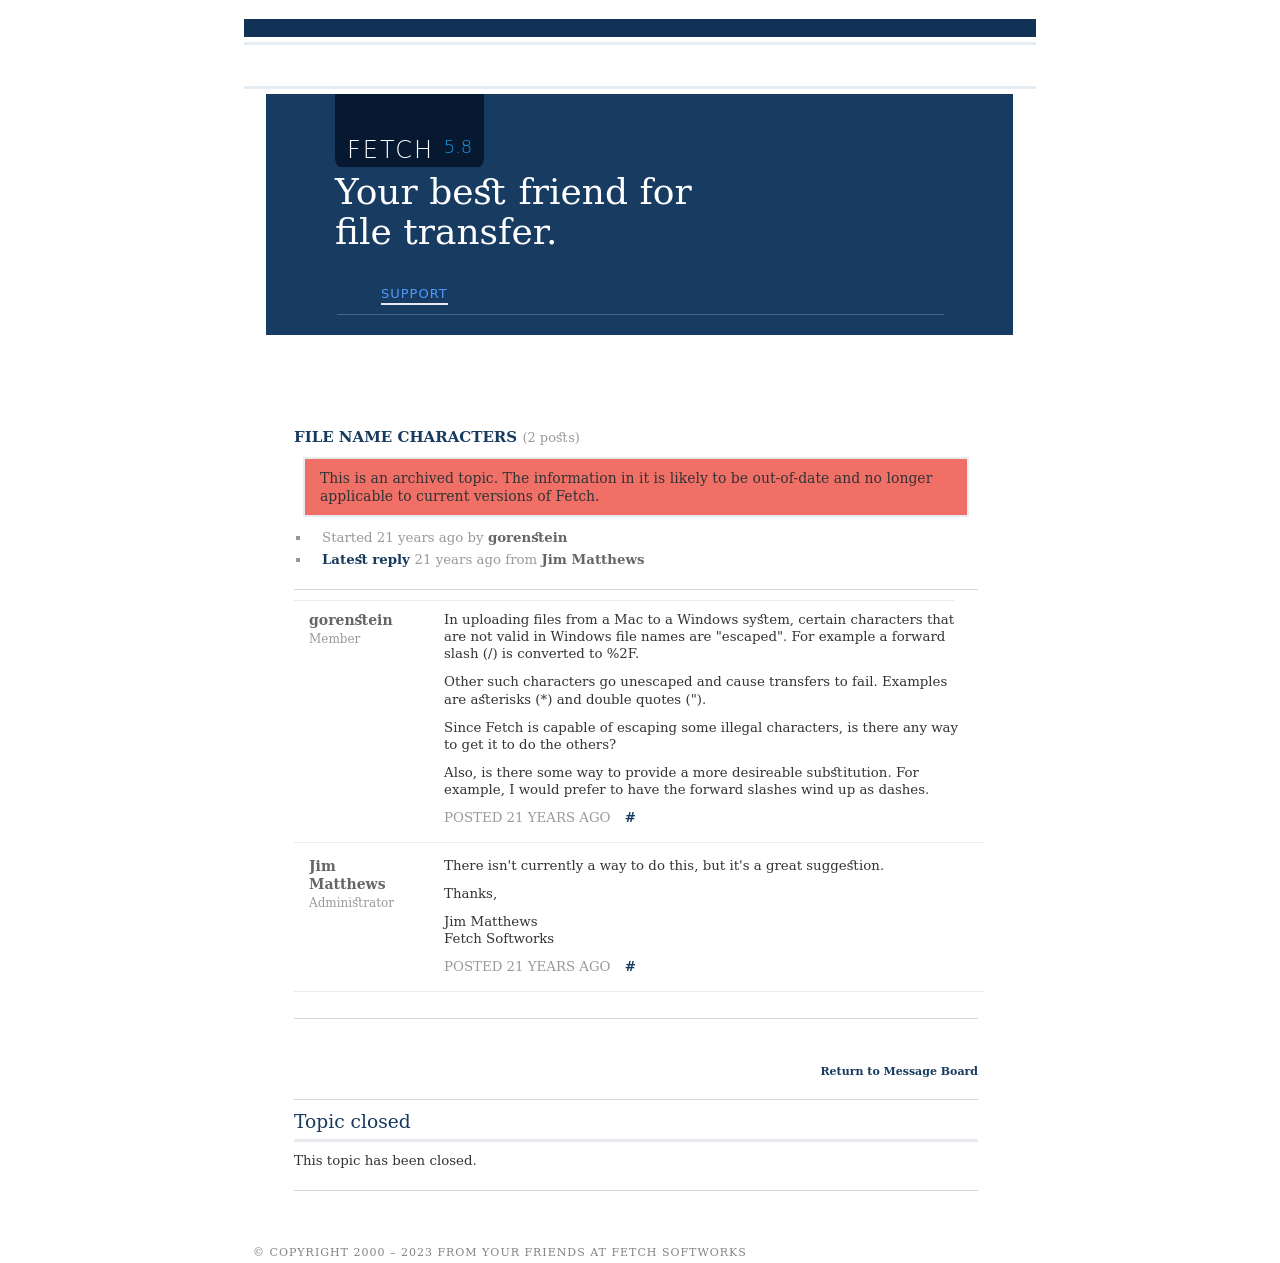Can you describe how the layout is organized in the interface shown in the image? The interface displayed in the image shows a structured and clean layout typical of forum designs. It features a top navigation header with links to various sections like news and store, indicating a practical approach for user navigation. The central part of the page focuses on the forum posts, where discussions are neatly categorized. Each post displays a subject, the member's name, and time since posting, enhancing the readability. The posts are contained within bounded sections which help in segregating discussions clearly. The footer seems to offer copyright, contact, and additional information, consistent with standard website practices, ensuring users have access to necessary information. 